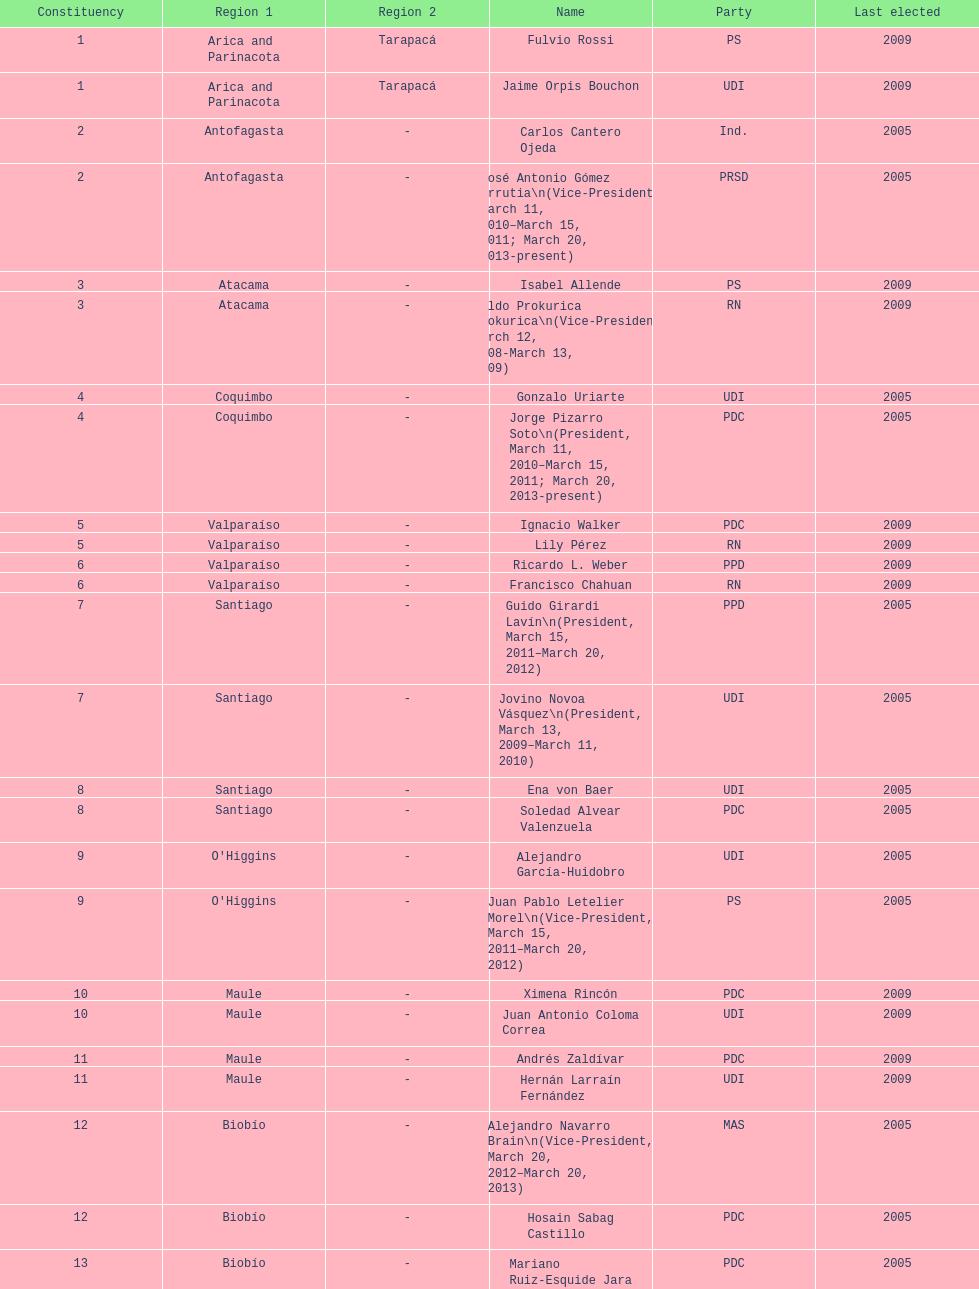What is the total number of constituencies? 19. 